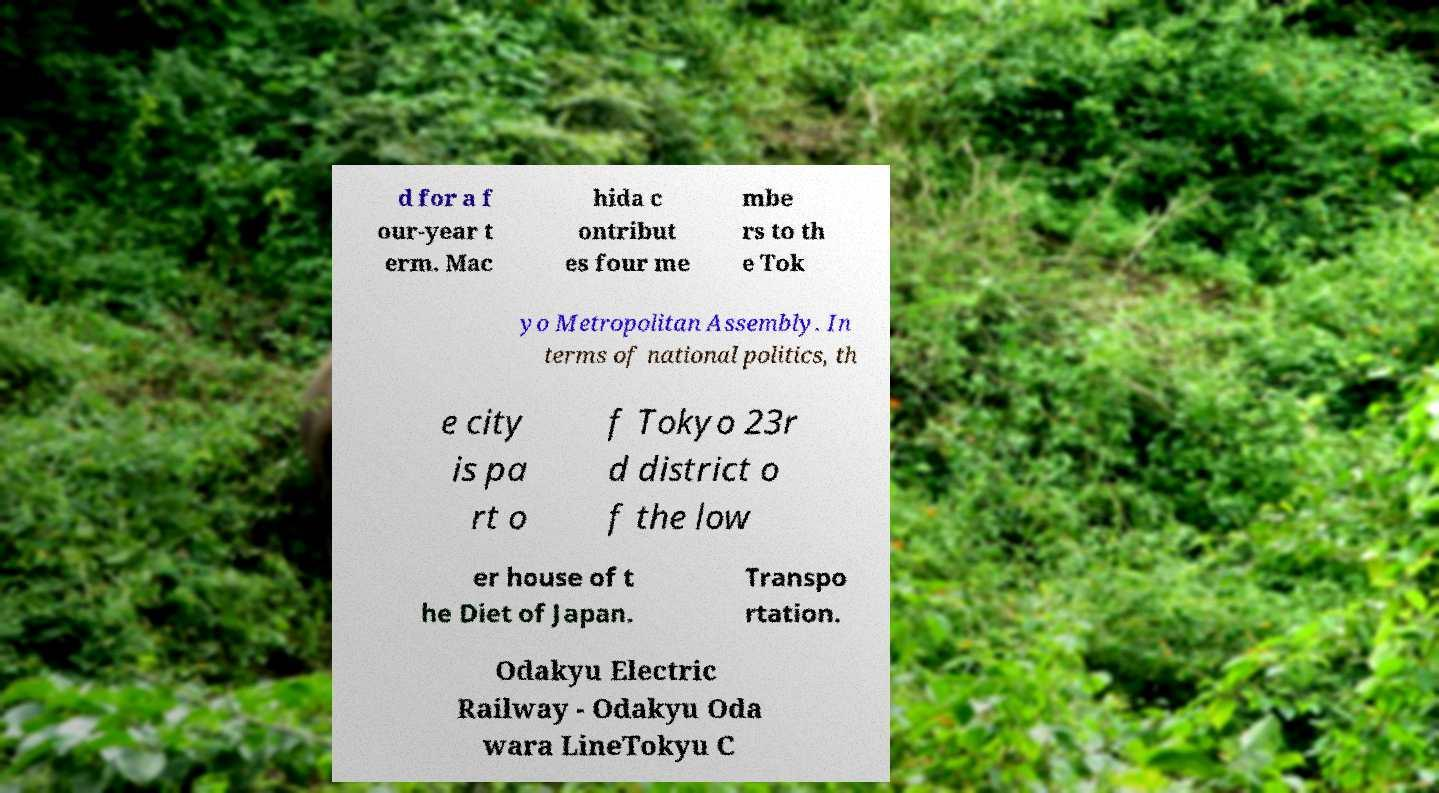Could you assist in decoding the text presented in this image and type it out clearly? d for a f our-year t erm. Mac hida c ontribut es four me mbe rs to th e Tok yo Metropolitan Assembly. In terms of national politics, th e city is pa rt o f Tokyo 23r d district o f the low er house of t he Diet of Japan. Transpo rtation. Odakyu Electric Railway - Odakyu Oda wara LineTokyu C 